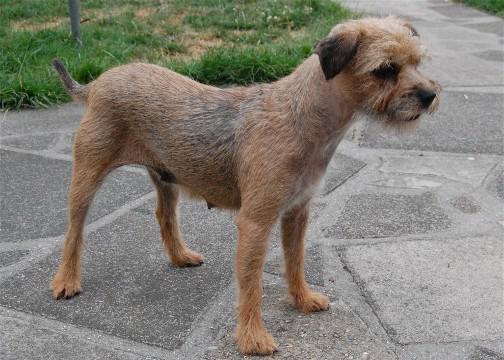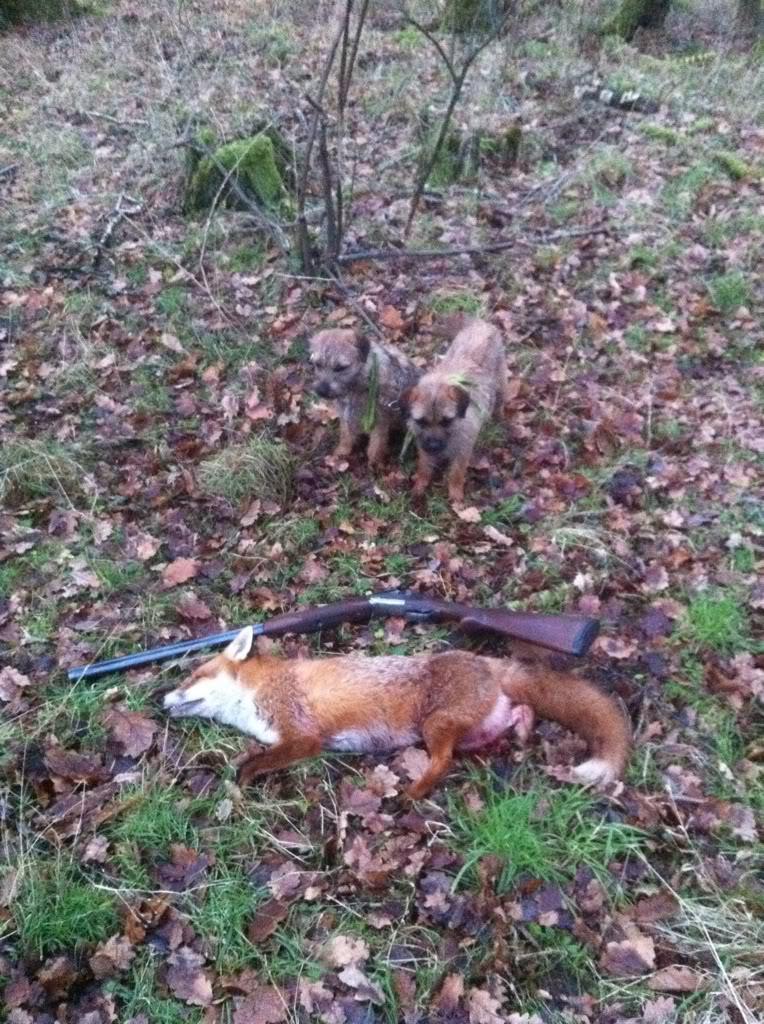The first image is the image on the left, the second image is the image on the right. Evaluate the accuracy of this statement regarding the images: "There are at least two animals in the image on the right.". Is it true? Answer yes or no. Yes. The first image is the image on the left, the second image is the image on the right. Evaluate the accuracy of this statement regarding the images: "Dog are shown with a dead animal in at least one of the images.". Is it true? Answer yes or no. Yes. 